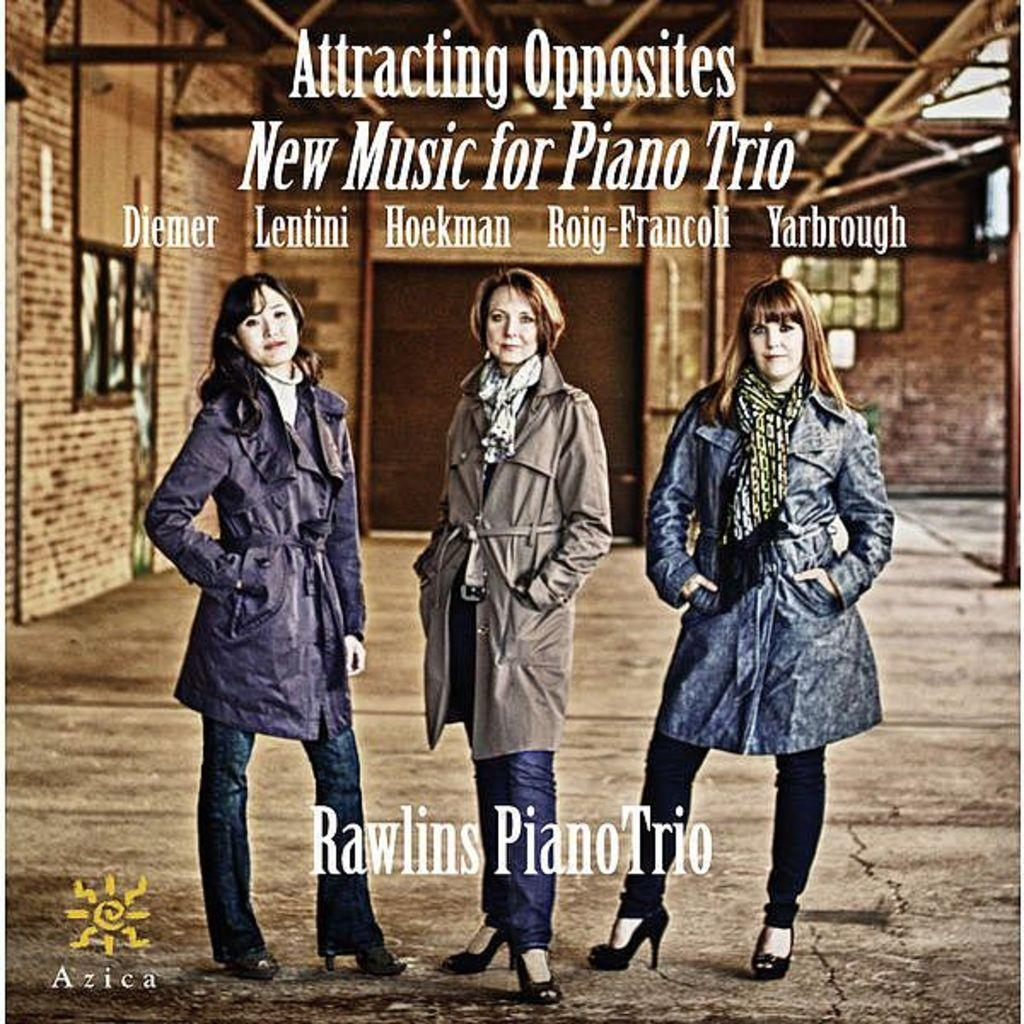What is featured on the poster in the image? There is a poster with text in the image. Where are the persons in the image located? The persons are standing under a shed in the image. What can be seen in the background of the image? There is a building in the background of the image. What type of beast is hiding under the shed in the image? There is no beast present in the image; it features persons standing under a shed. How many bikes are parked under the shed in the image? There is no bike present in the image; it only shows persons standing under a shed. 